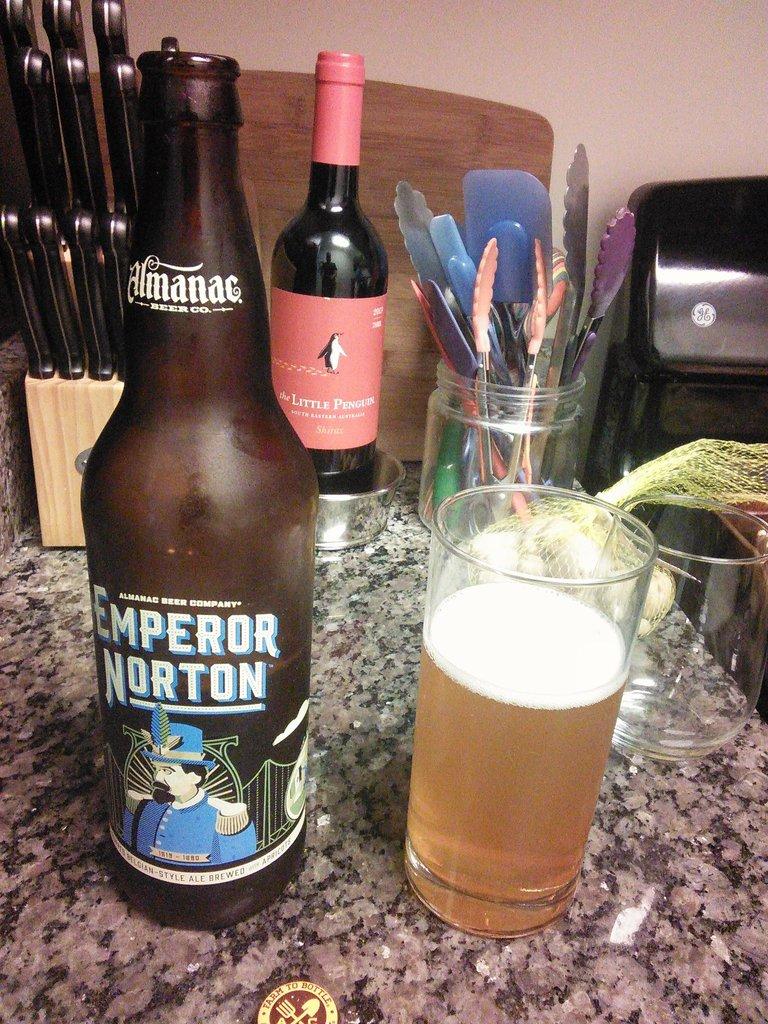What kind of beer is the brand on the left?
Ensure brevity in your answer.  Emperor norton. What is the name of the beer company?
Offer a terse response. Almanac. 